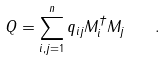Convert formula to latex. <formula><loc_0><loc_0><loc_500><loc_500>Q = \sum _ { i , j = 1 } ^ { n } q _ { i j } M _ { i } ^ { \dagger } M _ { j } \quad .</formula> 